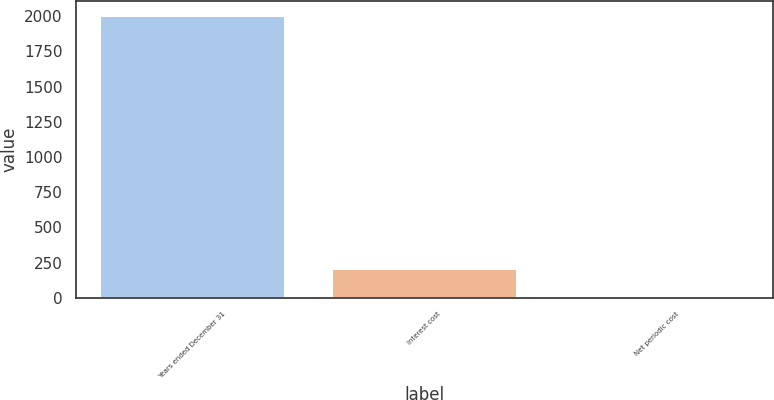<chart> <loc_0><loc_0><loc_500><loc_500><bar_chart><fcel>Years ended December 31<fcel>Interest cost<fcel>Net periodic cost<nl><fcel>2008<fcel>215.02<fcel>15.8<nl></chart> 